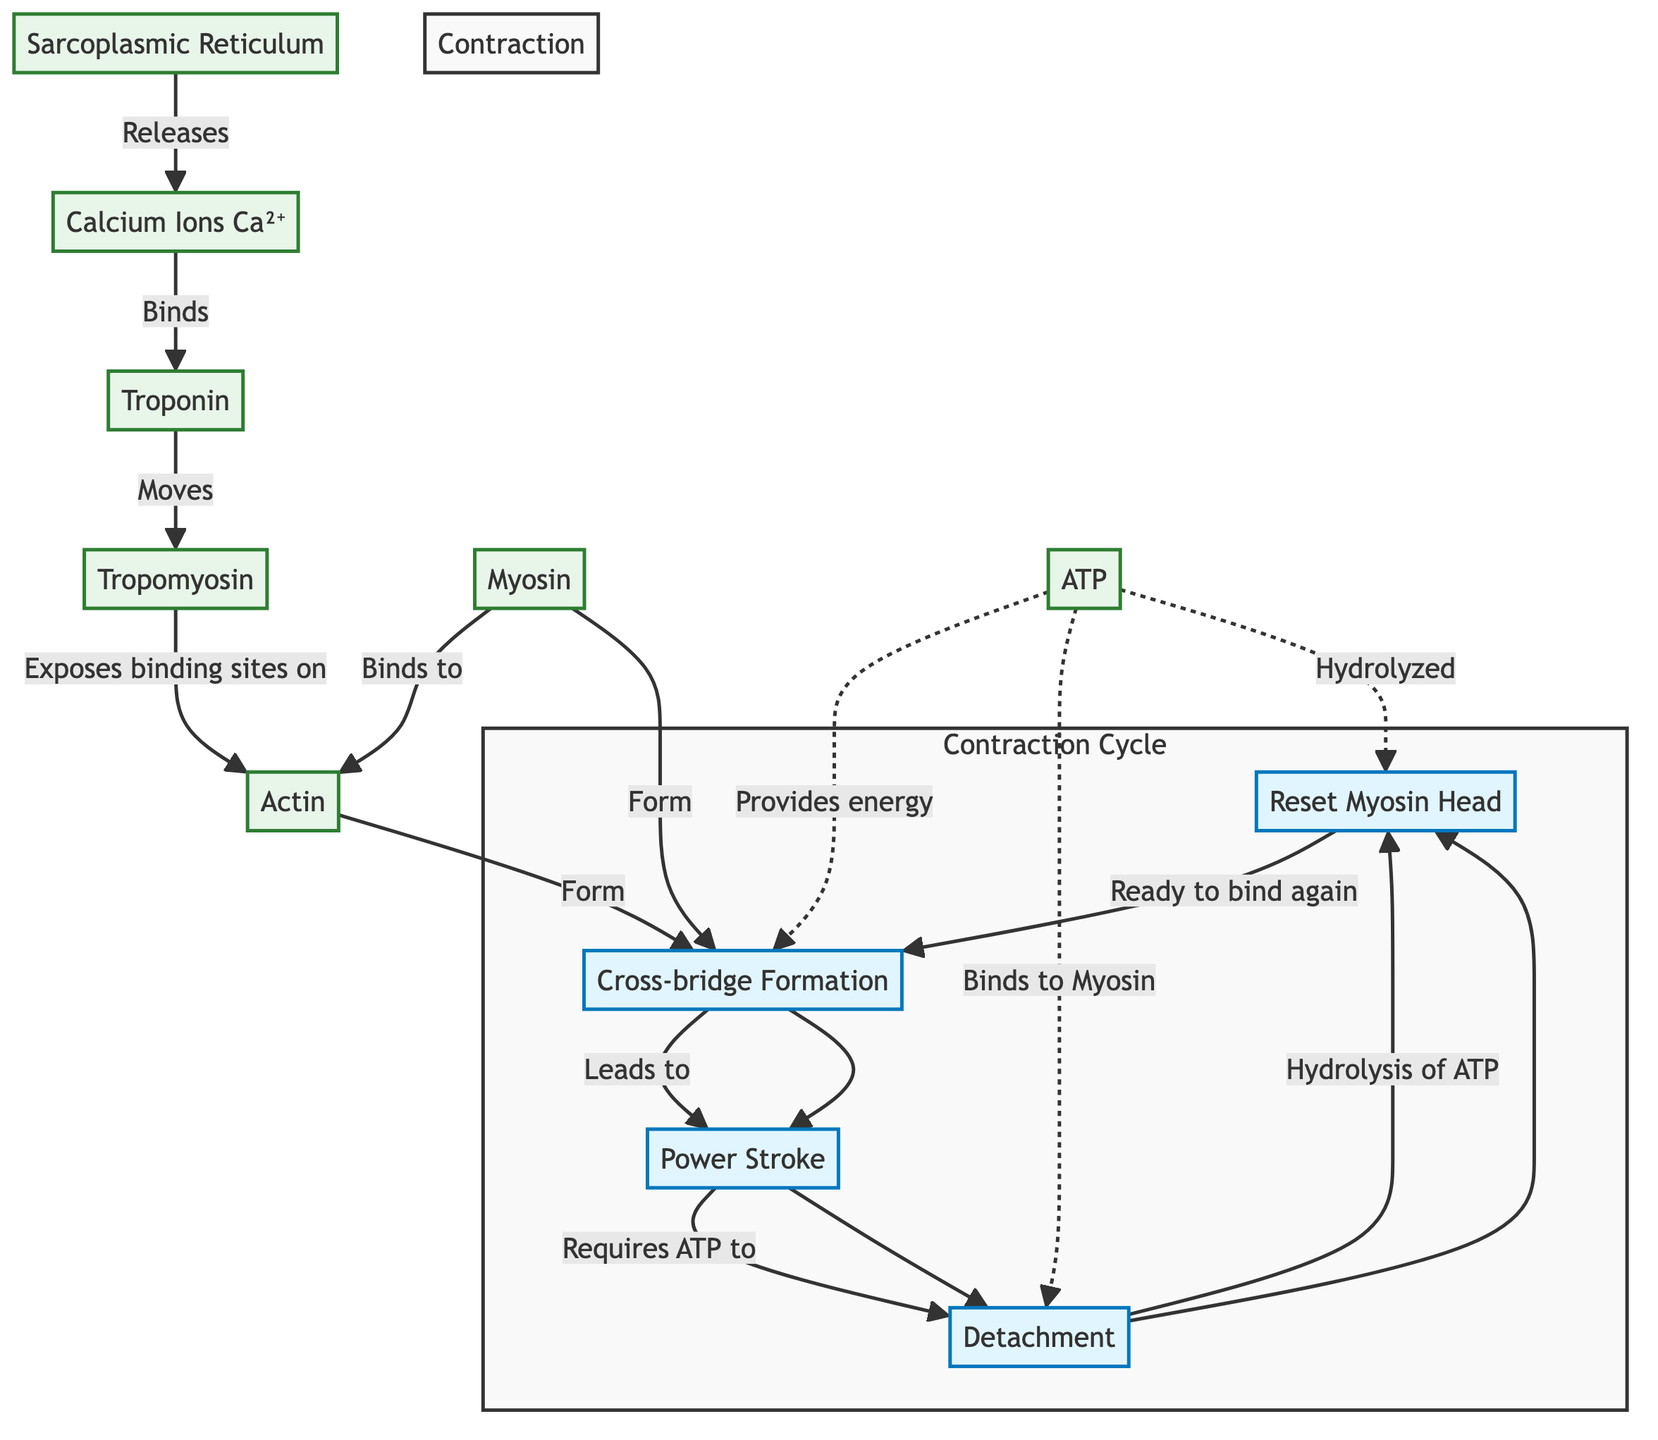What process follows cross-bridge formation? In the contraction cycle, after cross-bridge formation (CB), the next step is the power stroke (PS), as indicated by the directional flow from CB to PS.
Answer: Power Stroke What binds to troponin? According to the diagram, calcium ions (Ca²⁺) bind to troponin (T) as indicated by the arrow pointing from Ca to T.
Answer: Calcium Ions How many muscle contraction stages are shown in the diagram? The contraction cycle includes four distinct stages: cross-bridge formation, power stroke, detachment, and reset myosin head. Thus, there are four stages.
Answer: Four What provides energy for the power stroke? The diagram specifies that ATP provides energy for the power stroke, as indicated by the dashed arrow leading from ATP to the process of detachment (D).
Answer: ATP What happens to myosin during detachment? During the detachment stage (D), ATP binds to myosin, which is needed for myosin to release from actin. This relationship is represented by the arrow leading from ATP to D.
Answer: Binds to Myosin Which molecule is responsible for exposing the binding sites on actin? According to the diagram, tropomyosin (TM) moves after calcium ions bind to troponin, thereby exposing the binding sites on actin (A). This information is conveyed by the flow from TM to A.
Answer: Tropomyosin What event occurs after the power stroke? After the power stroke (PS), the next event is detachment (D) as indicated by the directional flow from PS to D in the contraction cycle.
Answer: Detachment Which component is hydrolyzed during the reset of the myosin head? The diagram clearly states that ATP is hydrolyzed during the reset myosin head stage (R), as indicated by the arrow emphasizing the hydrolysis of ATP leading to R.
Answer: ATP 